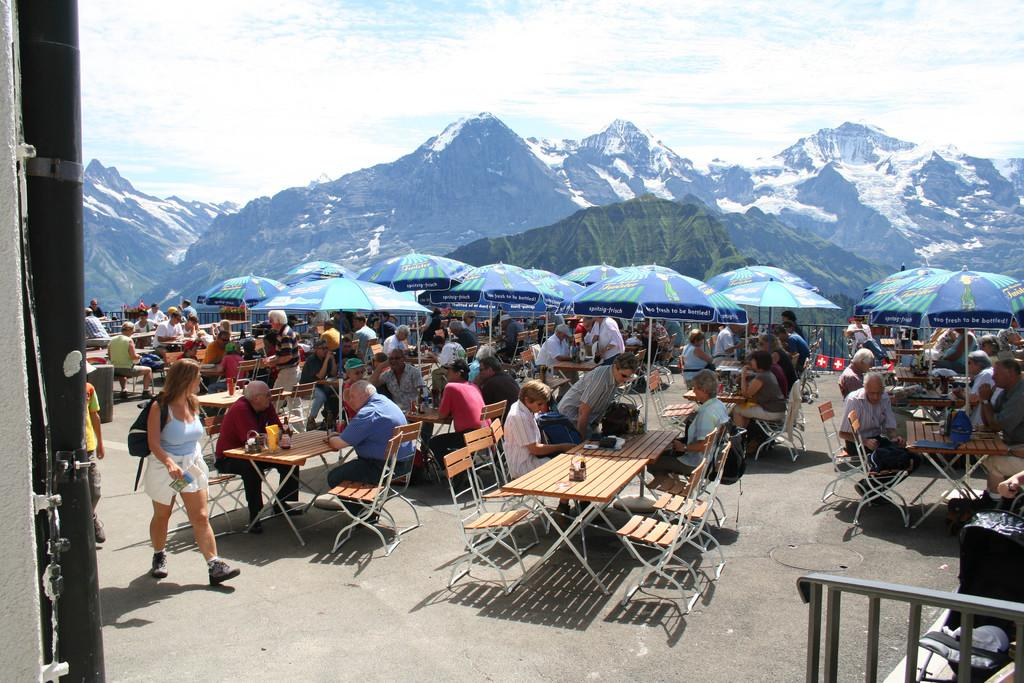How many people are in the image? There is a group of people in the image. What are the people doing in the image? The people are standing around a table and having food. What can be seen in the background of the image? There are mountains and the sky visible in the image. Can you see any clovers growing on the mountains in the image? There are no clovers visible in the image; the focus is on the group of people and the mountains in the background. 